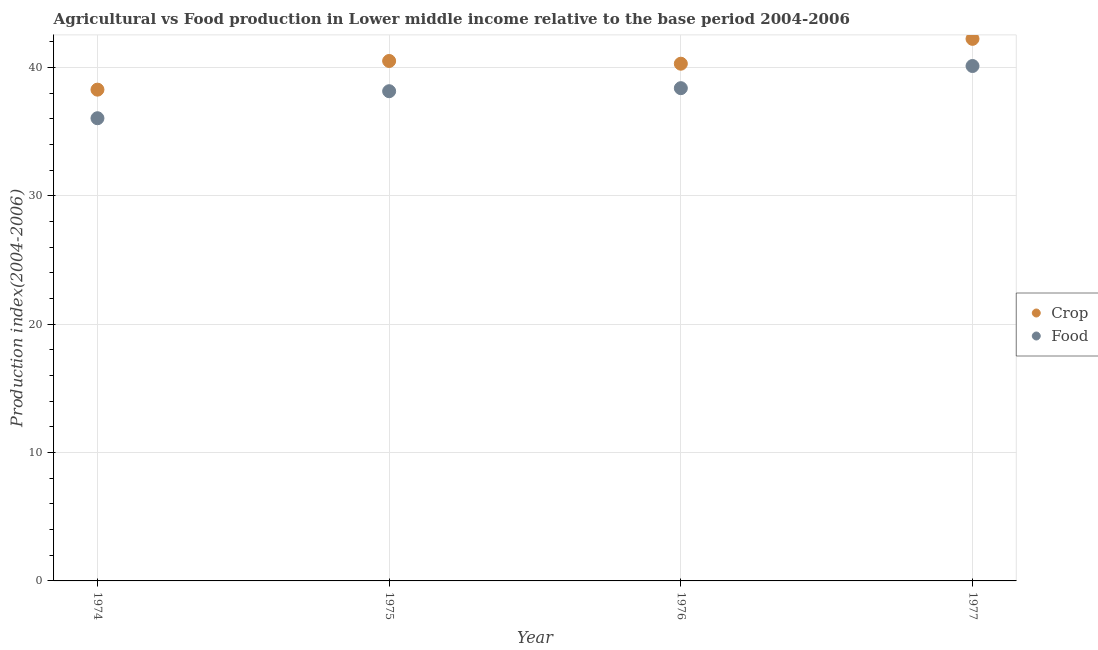What is the crop production index in 1977?
Your answer should be compact. 42.22. Across all years, what is the maximum crop production index?
Your response must be concise. 42.22. Across all years, what is the minimum food production index?
Provide a succinct answer. 36.04. In which year was the crop production index minimum?
Ensure brevity in your answer.  1974. What is the total crop production index in the graph?
Your response must be concise. 161.27. What is the difference between the food production index in 1974 and that in 1975?
Your answer should be compact. -2.1. What is the difference between the food production index in 1974 and the crop production index in 1976?
Keep it short and to the point. -4.25. What is the average food production index per year?
Ensure brevity in your answer.  38.17. In the year 1974, what is the difference between the food production index and crop production index?
Provide a succinct answer. -2.23. In how many years, is the food production index greater than 16?
Offer a terse response. 4. What is the ratio of the crop production index in 1975 to that in 1977?
Offer a terse response. 0.96. Is the food production index in 1975 less than that in 1976?
Your answer should be very brief. Yes. What is the difference between the highest and the second highest crop production index?
Provide a succinct answer. 1.72. What is the difference between the highest and the lowest crop production index?
Give a very brief answer. 3.96. In how many years, is the food production index greater than the average food production index taken over all years?
Your answer should be very brief. 2. Is the sum of the crop production index in 1976 and 1977 greater than the maximum food production index across all years?
Your answer should be very brief. Yes. Is the food production index strictly less than the crop production index over the years?
Provide a short and direct response. Yes. How many dotlines are there?
Your answer should be very brief. 2. How many years are there in the graph?
Offer a terse response. 4. What is the difference between two consecutive major ticks on the Y-axis?
Offer a terse response. 10. Are the values on the major ticks of Y-axis written in scientific E-notation?
Ensure brevity in your answer.  No. Does the graph contain any zero values?
Provide a short and direct response. No. How are the legend labels stacked?
Your response must be concise. Vertical. What is the title of the graph?
Your answer should be very brief. Agricultural vs Food production in Lower middle income relative to the base period 2004-2006. Does "Attending school" appear as one of the legend labels in the graph?
Provide a short and direct response. No. What is the label or title of the X-axis?
Provide a short and direct response. Year. What is the label or title of the Y-axis?
Ensure brevity in your answer.  Production index(2004-2006). What is the Production index(2004-2006) of Crop in 1974?
Your answer should be very brief. 38.27. What is the Production index(2004-2006) in Food in 1974?
Ensure brevity in your answer.  36.04. What is the Production index(2004-2006) of Crop in 1975?
Ensure brevity in your answer.  40.5. What is the Production index(2004-2006) of Food in 1975?
Keep it short and to the point. 38.14. What is the Production index(2004-2006) of Crop in 1976?
Offer a terse response. 40.29. What is the Production index(2004-2006) of Food in 1976?
Offer a very short reply. 38.38. What is the Production index(2004-2006) of Crop in 1977?
Keep it short and to the point. 42.22. What is the Production index(2004-2006) of Food in 1977?
Give a very brief answer. 40.11. Across all years, what is the maximum Production index(2004-2006) in Crop?
Keep it short and to the point. 42.22. Across all years, what is the maximum Production index(2004-2006) of Food?
Make the answer very short. 40.11. Across all years, what is the minimum Production index(2004-2006) in Crop?
Provide a short and direct response. 38.27. Across all years, what is the minimum Production index(2004-2006) in Food?
Provide a succinct answer. 36.04. What is the total Production index(2004-2006) of Crop in the graph?
Provide a succinct answer. 161.27. What is the total Production index(2004-2006) of Food in the graph?
Offer a terse response. 152.67. What is the difference between the Production index(2004-2006) in Crop in 1974 and that in 1975?
Keep it short and to the point. -2.23. What is the difference between the Production index(2004-2006) in Food in 1974 and that in 1975?
Your response must be concise. -2.1. What is the difference between the Production index(2004-2006) in Crop in 1974 and that in 1976?
Give a very brief answer. -2.02. What is the difference between the Production index(2004-2006) in Food in 1974 and that in 1976?
Make the answer very short. -2.34. What is the difference between the Production index(2004-2006) of Crop in 1974 and that in 1977?
Your answer should be very brief. -3.96. What is the difference between the Production index(2004-2006) of Food in 1974 and that in 1977?
Your answer should be compact. -4.07. What is the difference between the Production index(2004-2006) in Crop in 1975 and that in 1976?
Offer a very short reply. 0.21. What is the difference between the Production index(2004-2006) of Food in 1975 and that in 1976?
Your answer should be very brief. -0.24. What is the difference between the Production index(2004-2006) in Crop in 1975 and that in 1977?
Your answer should be very brief. -1.72. What is the difference between the Production index(2004-2006) of Food in 1975 and that in 1977?
Make the answer very short. -1.96. What is the difference between the Production index(2004-2006) in Crop in 1976 and that in 1977?
Ensure brevity in your answer.  -1.94. What is the difference between the Production index(2004-2006) of Food in 1976 and that in 1977?
Offer a terse response. -1.73. What is the difference between the Production index(2004-2006) in Crop in 1974 and the Production index(2004-2006) in Food in 1975?
Your response must be concise. 0.12. What is the difference between the Production index(2004-2006) in Crop in 1974 and the Production index(2004-2006) in Food in 1976?
Offer a very short reply. -0.12. What is the difference between the Production index(2004-2006) in Crop in 1974 and the Production index(2004-2006) in Food in 1977?
Provide a short and direct response. -1.84. What is the difference between the Production index(2004-2006) of Crop in 1975 and the Production index(2004-2006) of Food in 1976?
Your answer should be compact. 2.12. What is the difference between the Production index(2004-2006) in Crop in 1975 and the Production index(2004-2006) in Food in 1977?
Ensure brevity in your answer.  0.39. What is the difference between the Production index(2004-2006) of Crop in 1976 and the Production index(2004-2006) of Food in 1977?
Provide a short and direct response. 0.18. What is the average Production index(2004-2006) of Crop per year?
Offer a terse response. 40.32. What is the average Production index(2004-2006) in Food per year?
Ensure brevity in your answer.  38.17. In the year 1974, what is the difference between the Production index(2004-2006) in Crop and Production index(2004-2006) in Food?
Your answer should be compact. 2.23. In the year 1975, what is the difference between the Production index(2004-2006) in Crop and Production index(2004-2006) in Food?
Your answer should be compact. 2.35. In the year 1976, what is the difference between the Production index(2004-2006) of Crop and Production index(2004-2006) of Food?
Your response must be concise. 1.91. In the year 1977, what is the difference between the Production index(2004-2006) in Crop and Production index(2004-2006) in Food?
Give a very brief answer. 2.12. What is the ratio of the Production index(2004-2006) in Crop in 1974 to that in 1975?
Your answer should be very brief. 0.94. What is the ratio of the Production index(2004-2006) in Food in 1974 to that in 1975?
Offer a very short reply. 0.94. What is the ratio of the Production index(2004-2006) in Crop in 1974 to that in 1976?
Give a very brief answer. 0.95. What is the ratio of the Production index(2004-2006) of Food in 1974 to that in 1976?
Keep it short and to the point. 0.94. What is the ratio of the Production index(2004-2006) of Crop in 1974 to that in 1977?
Ensure brevity in your answer.  0.91. What is the ratio of the Production index(2004-2006) in Food in 1974 to that in 1977?
Provide a succinct answer. 0.9. What is the ratio of the Production index(2004-2006) of Crop in 1975 to that in 1977?
Provide a succinct answer. 0.96. What is the ratio of the Production index(2004-2006) in Food in 1975 to that in 1977?
Provide a succinct answer. 0.95. What is the ratio of the Production index(2004-2006) in Crop in 1976 to that in 1977?
Make the answer very short. 0.95. What is the ratio of the Production index(2004-2006) in Food in 1976 to that in 1977?
Provide a succinct answer. 0.96. What is the difference between the highest and the second highest Production index(2004-2006) of Crop?
Offer a terse response. 1.72. What is the difference between the highest and the second highest Production index(2004-2006) in Food?
Keep it short and to the point. 1.73. What is the difference between the highest and the lowest Production index(2004-2006) of Crop?
Your answer should be very brief. 3.96. What is the difference between the highest and the lowest Production index(2004-2006) in Food?
Provide a short and direct response. 4.07. 